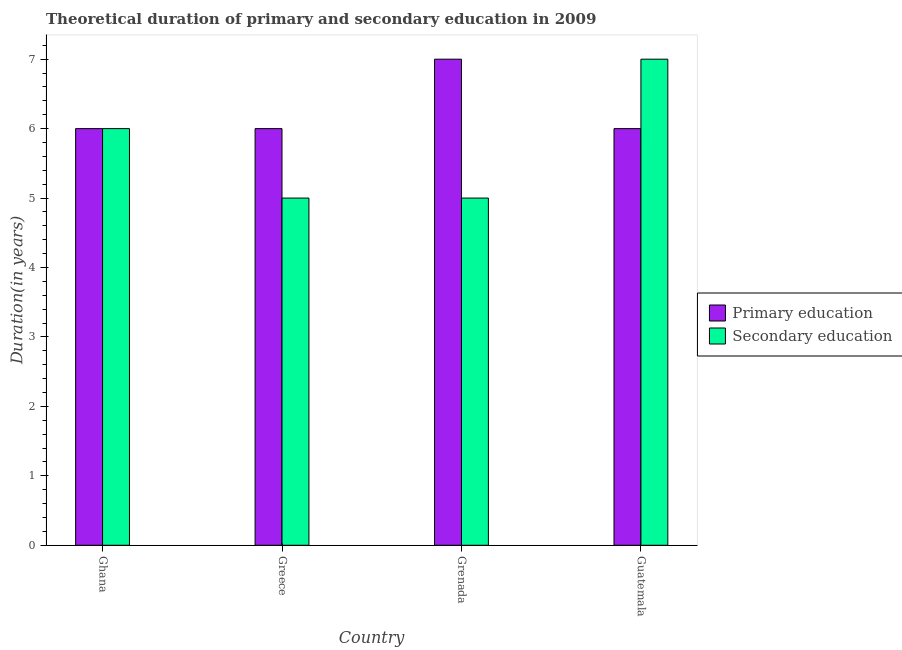How many different coloured bars are there?
Offer a terse response. 2. How many bars are there on the 1st tick from the left?
Your answer should be compact. 2. How many bars are there on the 4th tick from the right?
Keep it short and to the point. 2. What is the label of the 4th group of bars from the left?
Your answer should be very brief. Guatemala. In how many cases, is the number of bars for a given country not equal to the number of legend labels?
Make the answer very short. 0. What is the duration of secondary education in Grenada?
Keep it short and to the point. 5. Across all countries, what is the maximum duration of primary education?
Offer a very short reply. 7. In which country was the duration of secondary education maximum?
Your answer should be compact. Guatemala. In which country was the duration of primary education minimum?
Keep it short and to the point. Ghana. What is the total duration of secondary education in the graph?
Your answer should be very brief. 23. What is the difference between the duration of secondary education in Greece and that in Guatemala?
Keep it short and to the point. -2. What is the difference between the duration of secondary education in Guatemala and the duration of primary education in Greece?
Offer a terse response. 1. What is the average duration of secondary education per country?
Offer a terse response. 5.75. What is the difference between the duration of primary education and duration of secondary education in Greece?
Make the answer very short. 1. What is the ratio of the duration of secondary education in Grenada to that in Guatemala?
Your answer should be very brief. 0.71. Is the duration of primary education in Ghana less than that in Grenada?
Provide a short and direct response. Yes. What is the difference between the highest and the lowest duration of secondary education?
Keep it short and to the point. 2. In how many countries, is the duration of secondary education greater than the average duration of secondary education taken over all countries?
Keep it short and to the point. 2. Is the sum of the duration of primary education in Greece and Grenada greater than the maximum duration of secondary education across all countries?
Ensure brevity in your answer.  Yes. What does the 2nd bar from the left in Grenada represents?
Offer a terse response. Secondary education. How many bars are there?
Ensure brevity in your answer.  8. Are all the bars in the graph horizontal?
Keep it short and to the point. No. Are the values on the major ticks of Y-axis written in scientific E-notation?
Provide a succinct answer. No. Does the graph contain any zero values?
Give a very brief answer. No. Where does the legend appear in the graph?
Your answer should be compact. Center right. How many legend labels are there?
Keep it short and to the point. 2. How are the legend labels stacked?
Ensure brevity in your answer.  Vertical. What is the title of the graph?
Make the answer very short. Theoretical duration of primary and secondary education in 2009. Does "Quasi money growth" appear as one of the legend labels in the graph?
Offer a terse response. No. What is the label or title of the X-axis?
Provide a short and direct response. Country. What is the label or title of the Y-axis?
Offer a terse response. Duration(in years). What is the Duration(in years) of Primary education in Grenada?
Provide a succinct answer. 7. What is the Duration(in years) of Primary education in Guatemala?
Offer a terse response. 6. What is the Duration(in years) in Secondary education in Guatemala?
Provide a short and direct response. 7. Across all countries, what is the maximum Duration(in years) in Primary education?
Make the answer very short. 7. Across all countries, what is the minimum Duration(in years) in Secondary education?
Your response must be concise. 5. What is the difference between the Duration(in years) in Primary education in Ghana and that in Greece?
Offer a terse response. 0. What is the difference between the Duration(in years) in Primary education in Ghana and that in Grenada?
Keep it short and to the point. -1. What is the difference between the Duration(in years) of Secondary education in Ghana and that in Grenada?
Offer a very short reply. 1. What is the difference between the Duration(in years) in Primary education in Ghana and that in Guatemala?
Your answer should be very brief. 0. What is the difference between the Duration(in years) in Secondary education in Grenada and that in Guatemala?
Make the answer very short. -2. What is the difference between the Duration(in years) in Primary education in Greece and the Duration(in years) in Secondary education in Grenada?
Offer a very short reply. 1. What is the difference between the Duration(in years) of Primary education in Greece and the Duration(in years) of Secondary education in Guatemala?
Provide a short and direct response. -1. What is the difference between the Duration(in years) of Primary education in Grenada and the Duration(in years) of Secondary education in Guatemala?
Offer a very short reply. 0. What is the average Duration(in years) of Primary education per country?
Keep it short and to the point. 6.25. What is the average Duration(in years) in Secondary education per country?
Provide a succinct answer. 5.75. What is the difference between the Duration(in years) of Primary education and Duration(in years) of Secondary education in Ghana?
Ensure brevity in your answer.  0. What is the difference between the Duration(in years) in Primary education and Duration(in years) in Secondary education in Guatemala?
Make the answer very short. -1. What is the ratio of the Duration(in years) in Primary education in Ghana to that in Greece?
Keep it short and to the point. 1. What is the ratio of the Duration(in years) of Primary education in Ghana to that in Grenada?
Your answer should be very brief. 0.86. What is the ratio of the Duration(in years) in Secondary education in Greece to that in Grenada?
Your answer should be compact. 1. What is the ratio of the Duration(in years) of Primary education in Greece to that in Guatemala?
Ensure brevity in your answer.  1. What is the ratio of the Duration(in years) of Secondary education in Greece to that in Guatemala?
Provide a succinct answer. 0.71. What is the ratio of the Duration(in years) of Secondary education in Grenada to that in Guatemala?
Your answer should be very brief. 0.71. 